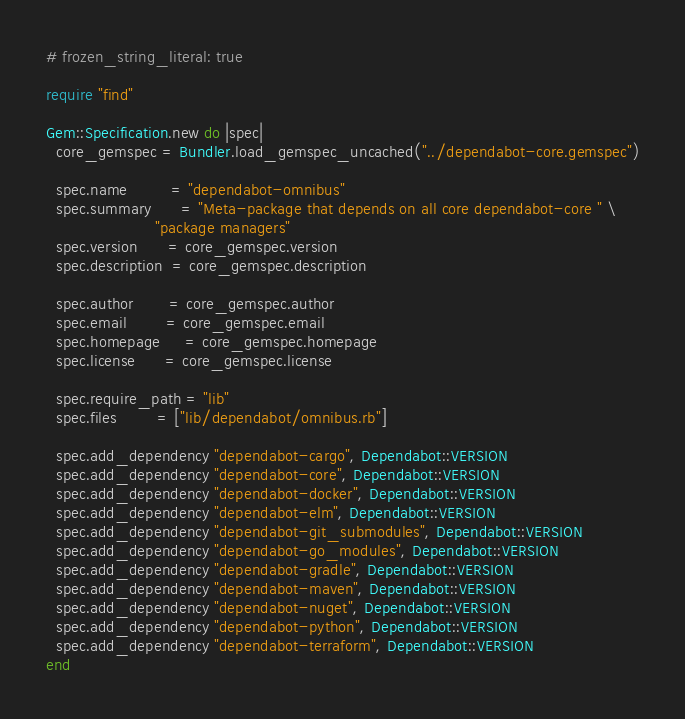<code> <loc_0><loc_0><loc_500><loc_500><_Ruby_># frozen_string_literal: true

require "find"

Gem::Specification.new do |spec|
  core_gemspec = Bundler.load_gemspec_uncached("../dependabot-core.gemspec")

  spec.name         = "dependabot-omnibus"
  spec.summary      = "Meta-package that depends on all core dependabot-core " \
                      "package managers"
  spec.version      = core_gemspec.version
  spec.description  = core_gemspec.description

  spec.author       = core_gemspec.author
  spec.email        = core_gemspec.email
  spec.homepage     = core_gemspec.homepage
  spec.license      = core_gemspec.license

  spec.require_path = "lib"
  spec.files        = ["lib/dependabot/omnibus.rb"]

  spec.add_dependency "dependabot-cargo", Dependabot::VERSION
  spec.add_dependency "dependabot-core", Dependabot::VERSION
  spec.add_dependency "dependabot-docker", Dependabot::VERSION
  spec.add_dependency "dependabot-elm", Dependabot::VERSION
  spec.add_dependency "dependabot-git_submodules", Dependabot::VERSION
  spec.add_dependency "dependabot-go_modules", Dependabot::VERSION
  spec.add_dependency "dependabot-gradle", Dependabot::VERSION
  spec.add_dependency "dependabot-maven", Dependabot::VERSION
  spec.add_dependency "dependabot-nuget", Dependabot::VERSION
  spec.add_dependency "dependabot-python", Dependabot::VERSION
  spec.add_dependency "dependabot-terraform", Dependabot::VERSION
end
</code> 